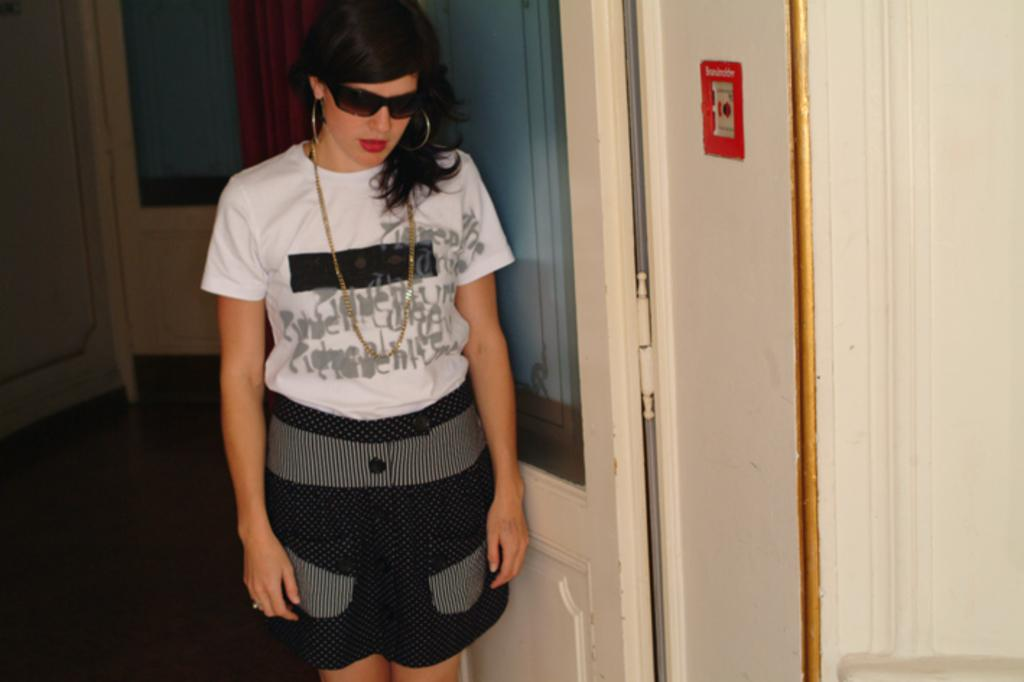Where was the image taken? The image is taken indoors. What is the main subject of the image? There is a woman standing in the middle of the image. What is the woman standing on? The woman is standing on the floor. What can be seen in the background of the image? There is a wall in the background of the image. What features are present on the wall? The wall has doors and a curtain associated with it. What type of government is depicted in the image? There is no depiction of a government in the image; it features a woman standing indoors. What is the role of the maid in the image? There is no maid present in the image. 